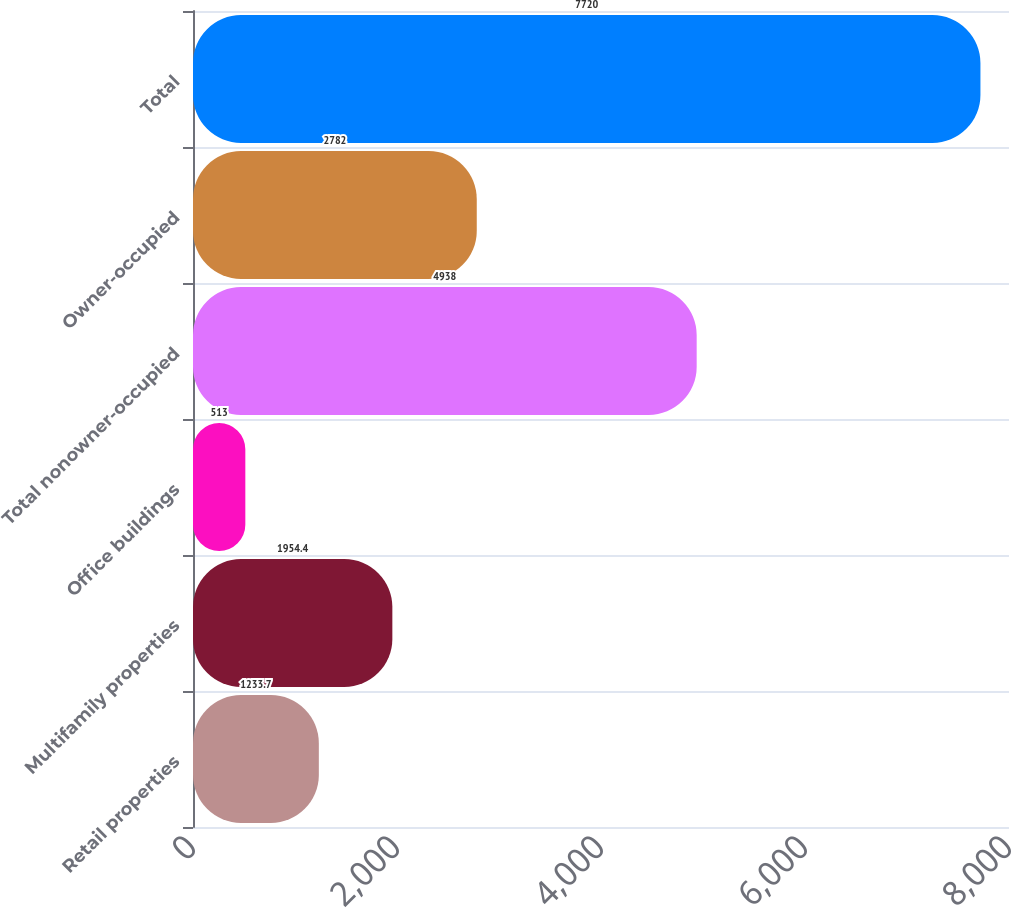Convert chart to OTSL. <chart><loc_0><loc_0><loc_500><loc_500><bar_chart><fcel>Retail properties<fcel>Multifamily properties<fcel>Office buildings<fcel>Total nonowner-occupied<fcel>Owner-occupied<fcel>Total<nl><fcel>1233.7<fcel>1954.4<fcel>513<fcel>4938<fcel>2782<fcel>7720<nl></chart> 